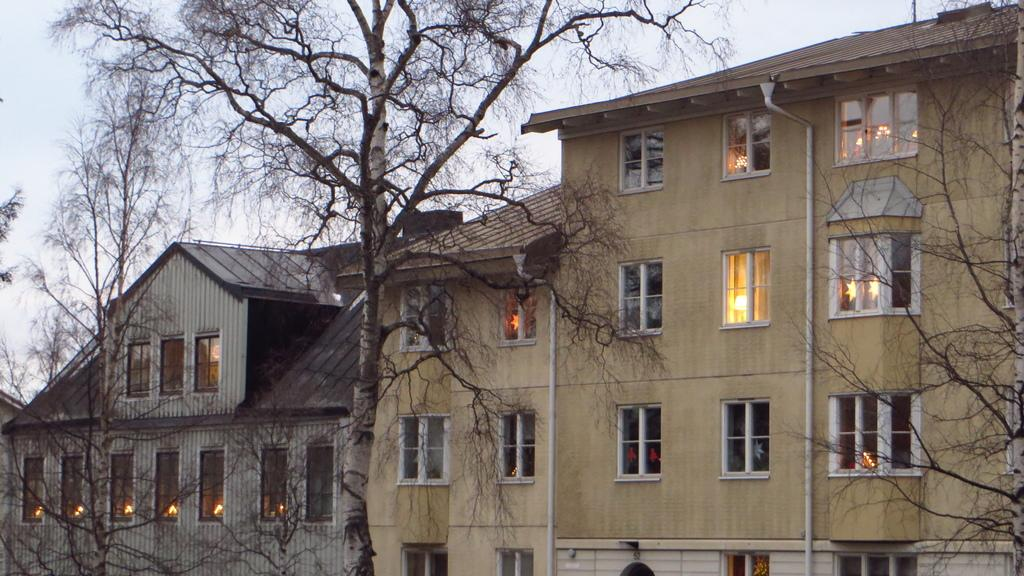What type of vegetation can be seen on both sides of the image? There are trees on the right side and the left side of the image. What can be seen in the buildings in the image? There are lights visible in the buildings. What is visible at the top of the image? The sky is visible at the top of the image. What type of honey can be seen dripping from the trees in the image? There is no honey present in the image; it features trees on both sides and lights in the buildings. What time of day is it in the image, considering the presence of the sun? The provided facts do not mention the presence of the sun, so it cannot be determined from the image. 